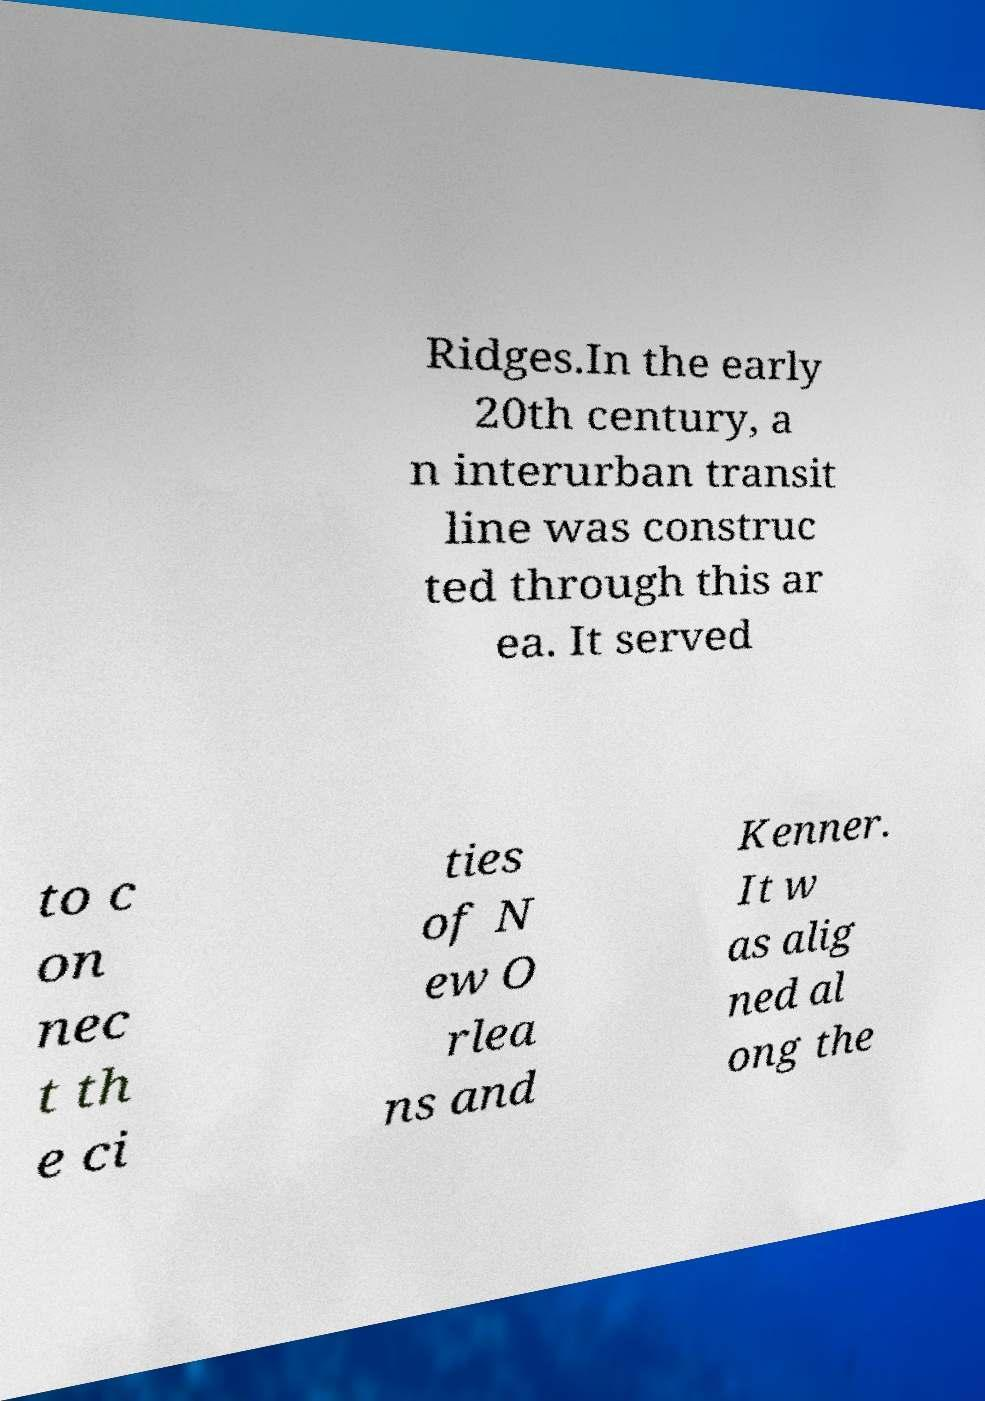Please read and relay the text visible in this image. What does it say? Ridges.In the early 20th century, a n interurban transit line was construc ted through this ar ea. It served to c on nec t th e ci ties of N ew O rlea ns and Kenner. It w as alig ned al ong the 